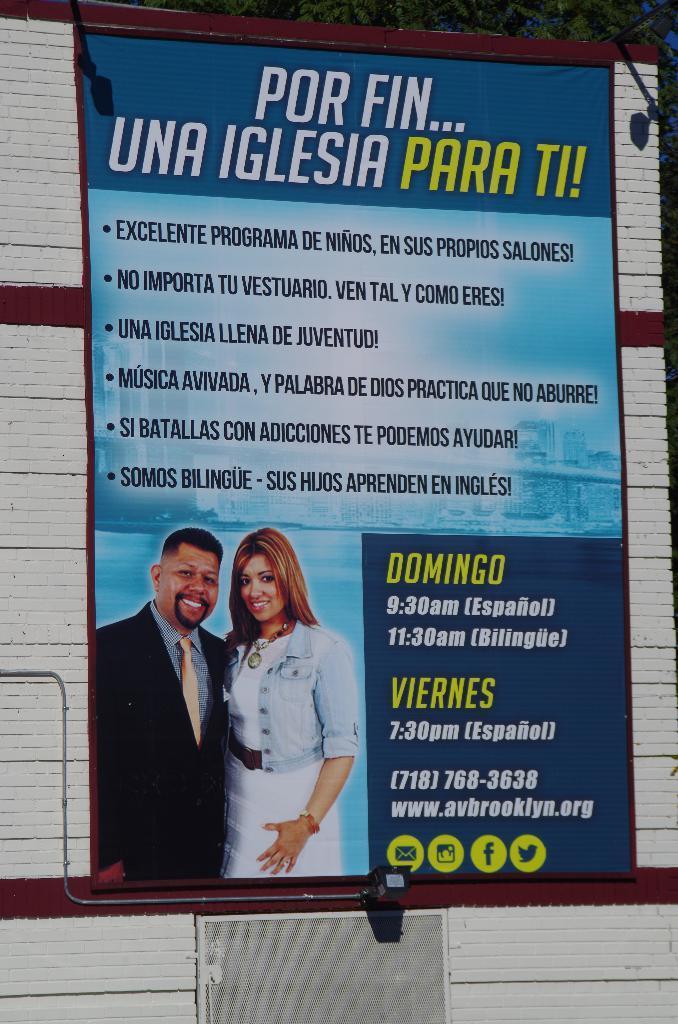Please provide a concise description of this image. In this image in the center there is a banner with some text written on it, and on the banner there is a image of man and a woman smiling. 